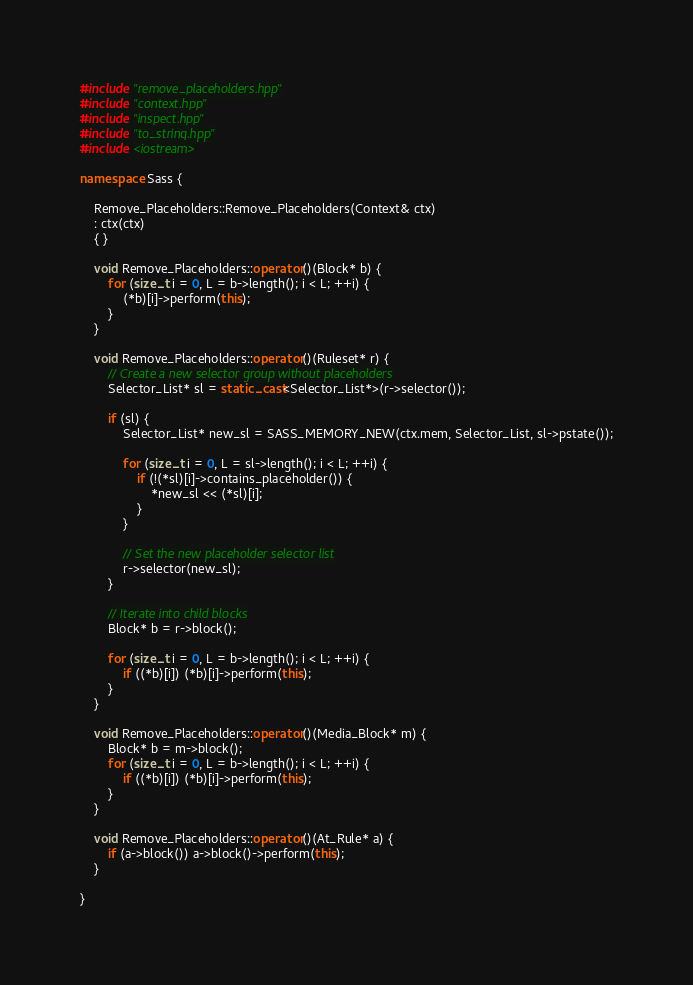<code> <loc_0><loc_0><loc_500><loc_500><_C++_>#include "remove_placeholders.hpp"
#include "context.hpp"
#include "inspect.hpp"
#include "to_string.hpp"
#include <iostream>

namespace Sass {

    Remove_Placeholders::Remove_Placeholders(Context& ctx)
    : ctx(ctx)
    { }

    void Remove_Placeholders::operator()(Block* b) {
        for (size_t i = 0, L = b->length(); i < L; ++i) {
            (*b)[i]->perform(this);
        }
    }

    void Remove_Placeholders::operator()(Ruleset* r) {
        // Create a new selector group without placeholders
        Selector_List* sl = static_cast<Selector_List*>(r->selector());

        if (sl) {
            Selector_List* new_sl = SASS_MEMORY_NEW(ctx.mem, Selector_List, sl->pstate());

            for (size_t i = 0, L = sl->length(); i < L; ++i) {
                if (!(*sl)[i]->contains_placeholder()) {
                    *new_sl << (*sl)[i];
                }
            }

            // Set the new placeholder selector list
            r->selector(new_sl);
        }

        // Iterate into child blocks
        Block* b = r->block();

        for (size_t i = 0, L = b->length(); i < L; ++i) {
            if ((*b)[i]) (*b)[i]->perform(this);
        }
    }

    void Remove_Placeholders::operator()(Media_Block* m) {
        Block* b = m->block();
        for (size_t i = 0, L = b->length(); i < L; ++i) {
            if ((*b)[i]) (*b)[i]->perform(this);
        }
    }

    void Remove_Placeholders::operator()(At_Rule* a) {
        if (a->block()) a->block()->perform(this);
    }

}
</code> 